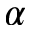Convert formula to latex. <formula><loc_0><loc_0><loc_500><loc_500>\alpha</formula> 